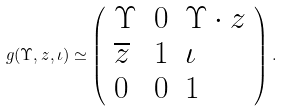Convert formula to latex. <formula><loc_0><loc_0><loc_500><loc_500>g ( \Upsilon , z , \iota ) \simeq \left ( \begin{array} { l l l } \Upsilon & 0 & \Upsilon \cdot z \\ \overline { z } & 1 & \iota \\ 0 & 0 & 1 \end{array} \right ) .</formula> 